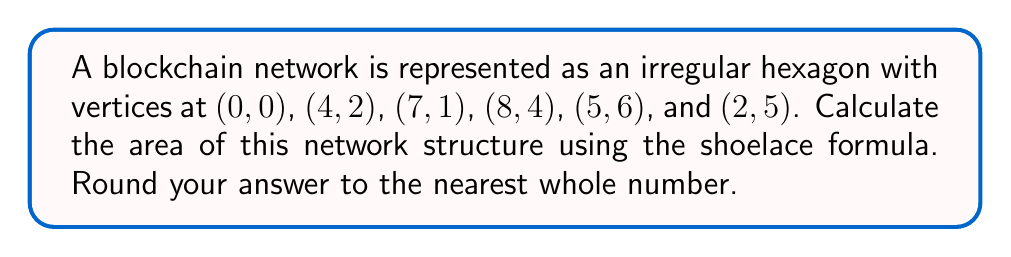Can you solve this math problem? To solve this problem, we'll use the shoelace formula (also known as the surveyor's formula) to calculate the area of the irregular hexagon. The steps are as follows:

1) The shoelace formula for a polygon with vertices $(x_1, y_1), (x_2, y_2), ..., (x_n, y_n)$ is:

   $$A = \frac{1}{2}|(x_1y_2 + x_2y_3 + ... + x_ny_1) - (y_1x_2 + y_2x_3 + ... + y_nx_1)|$$

2) Let's organize our vertices:
   $(x_1, y_1) = (0, 0)$
   $(x_2, y_2) = (4, 2)$
   $(x_3, y_3) = (7, 1)$
   $(x_4, y_4) = (8, 4)$
   $(x_5, y_5) = (5, 6)$
   $(x_6, y_6) = (2, 5)$

3) Now, let's apply the formula:

   $$A = \frac{1}{2}|(0\cdot2 + 4\cdot1 + 7\cdot4 + 8\cdot6 + 5\cdot5 + 2\cdot0) - (0\cdot4 + 2\cdot7 + 1\cdot8 + 4\cdot5 + 6\cdot2 + 5\cdot0)|$$

4) Simplify:
   $$A = \frac{1}{2}|(0 + 4 + 28 + 48 + 25 + 0) - (0 + 14 + 8 + 20 + 12 + 0)|$$
   $$A = \frac{1}{2}|105 - 54|$$
   $$A = \frac{1}{2}|51|$$
   $$A = \frac{51}{2}$$
   $$A = 25.5$$

5) Rounding to the nearest whole number:
   $$A \approx 26$$

[asy]
unitsize(20);
draw((0,0)--(4,2)--(7,1)--(8,4)--(5,6)--(2,5)--cycle);
dot((0,0)); dot((4,2)); dot((7,1)); dot((8,4)); dot((5,6)); dot((2,5));
label("(0,0)", (0,0), SW);
label("(4,2)", (4,2), SE);
label("(7,1)", (7,1), SE);
label("(8,4)", (8,4), E);
label("(5,6)", (5,6), N);
label("(2,5)", (2,5), NW);
[/asy]
Answer: 26 square units 